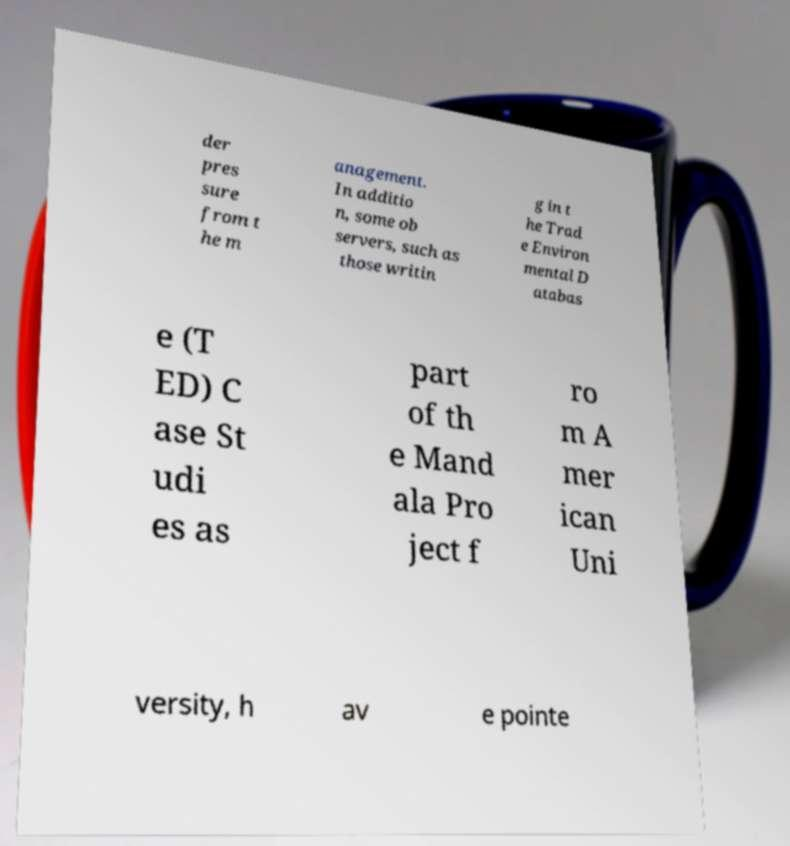What messages or text are displayed in this image? I need them in a readable, typed format. der pres sure from t he m anagement. In additio n, some ob servers, such as those writin g in t he Trad e Environ mental D atabas e (T ED) C ase St udi es as part of th e Mand ala Pro ject f ro m A mer ican Uni versity, h av e pointe 